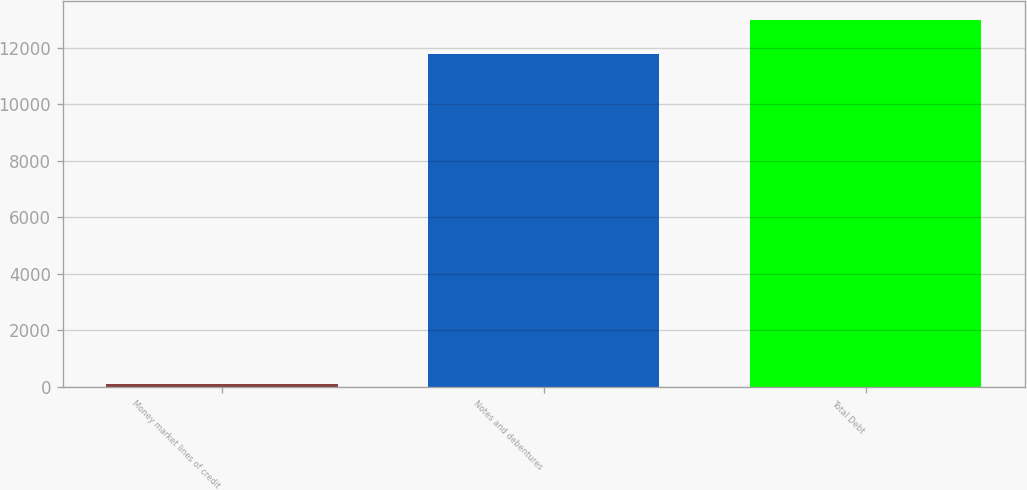Convert chart to OTSL. <chart><loc_0><loc_0><loc_500><loc_500><bar_chart><fcel>Money market lines of credit<fcel>Notes and debentures<fcel>Total Debt<nl><fcel>91<fcel>11765<fcel>12990.4<nl></chart> 